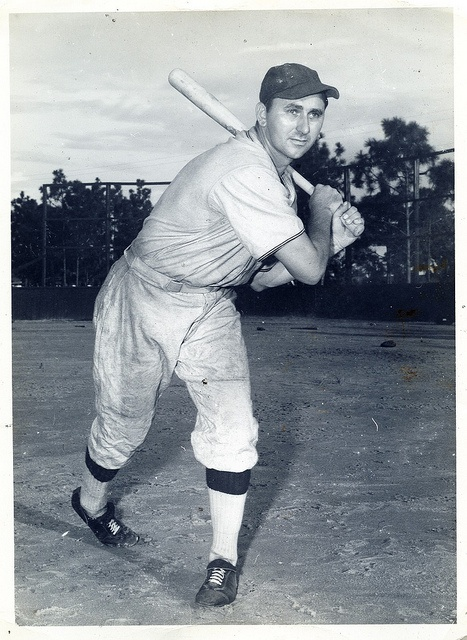Describe the objects in this image and their specific colors. I can see people in white, lightgray, darkgray, gray, and black tones and baseball bat in white, lightgray, darkgray, and gray tones in this image. 